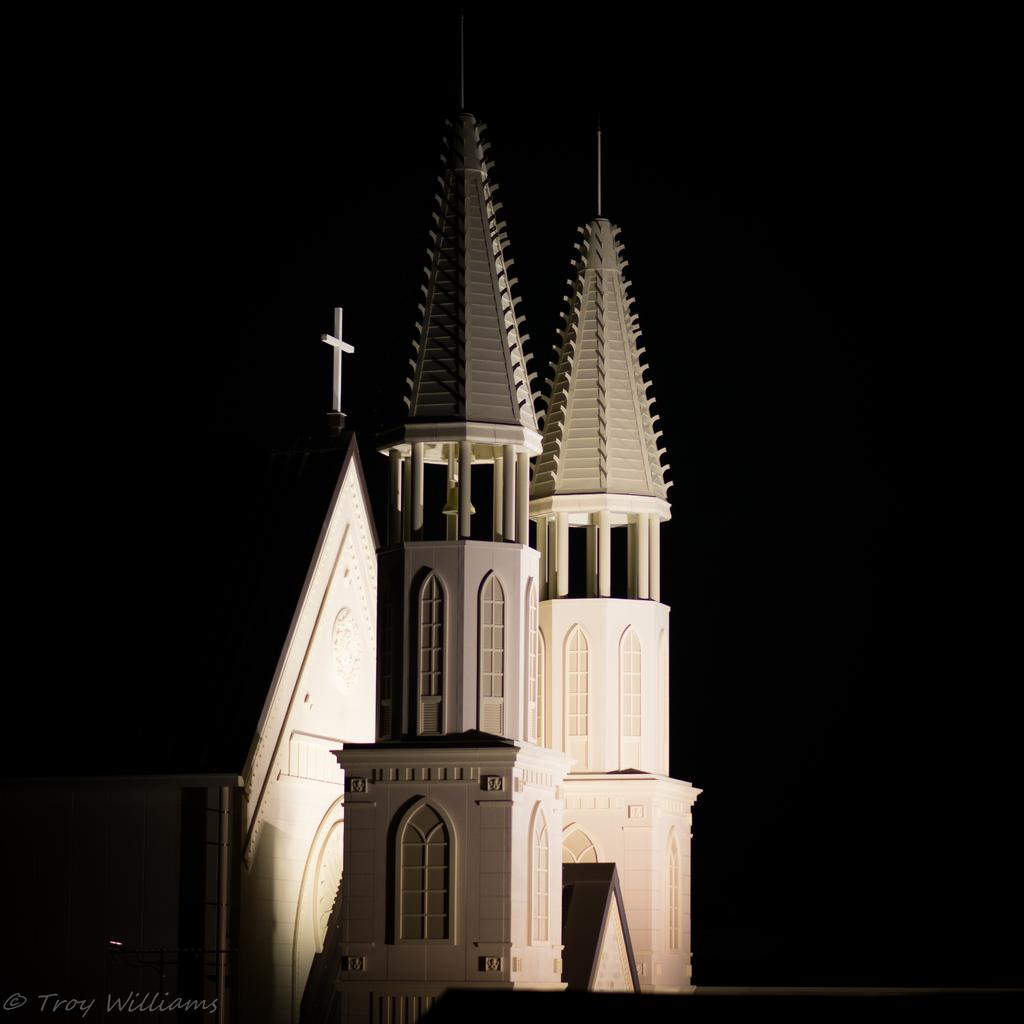What is the main subject of the image? The main subject of the image is a building. What specific features can be observed on the building? The building has windows. What color is the background of the image? The background of the image is black. How many oranges are hanging from the windows of the building in the image? There are no oranges present in the image, and therefore no such activity can be observed. 